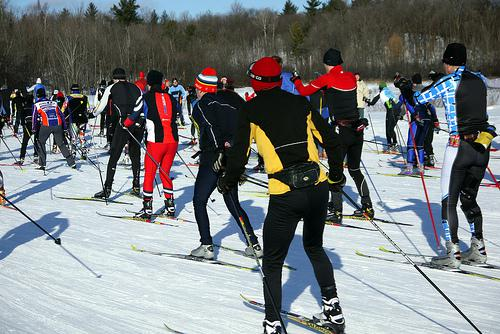Question: how is the weather?
Choices:
A. It is hot.
B. It is freezing.
C. It is cold.
D. It is cool.
Answer with the letter. Answer: C Question: who is wearing red?
Choices:
A. A man.
B. A boy.
C. A girl.
D. A woman.
Answer with the letter. Answer: D Question: what are the skiers wearing?
Choices:
A. Goggles.
B. Gloves.
C. Scarves.
D. Hats.
Answer with the letter. Answer: D Question: what color are most skiers's suits?
Choices:
A. Black.
B. Brown.
C. Blue.
D. Grey.
Answer with the letter. Answer: A Question: where are these people?
Choices:
A. In the cabin.
B. On the mountain.
C. On the ski slope.
D. In the ski lift.
Answer with the letter. Answer: C Question: what is next to the skiers?
Choices:
A. Bushes.
B. Trees.
C. Skiers.
D. Rocks.
Answer with the letter. Answer: B Question: why are they carrying poles?
Choices:
A. To sell.
B. To build.
C. To ski.
D. To remodel.
Answer with the letter. Answer: C 